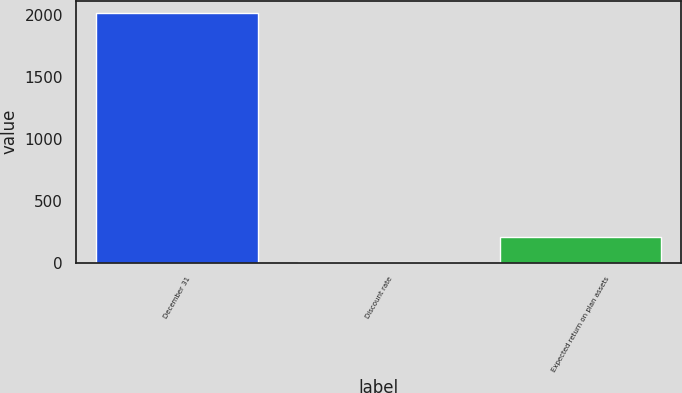Convert chart to OTSL. <chart><loc_0><loc_0><loc_500><loc_500><bar_chart><fcel>December 31<fcel>Discount rate<fcel>Expected return on plan assets<nl><fcel>2012<fcel>4.17<fcel>204.95<nl></chart> 